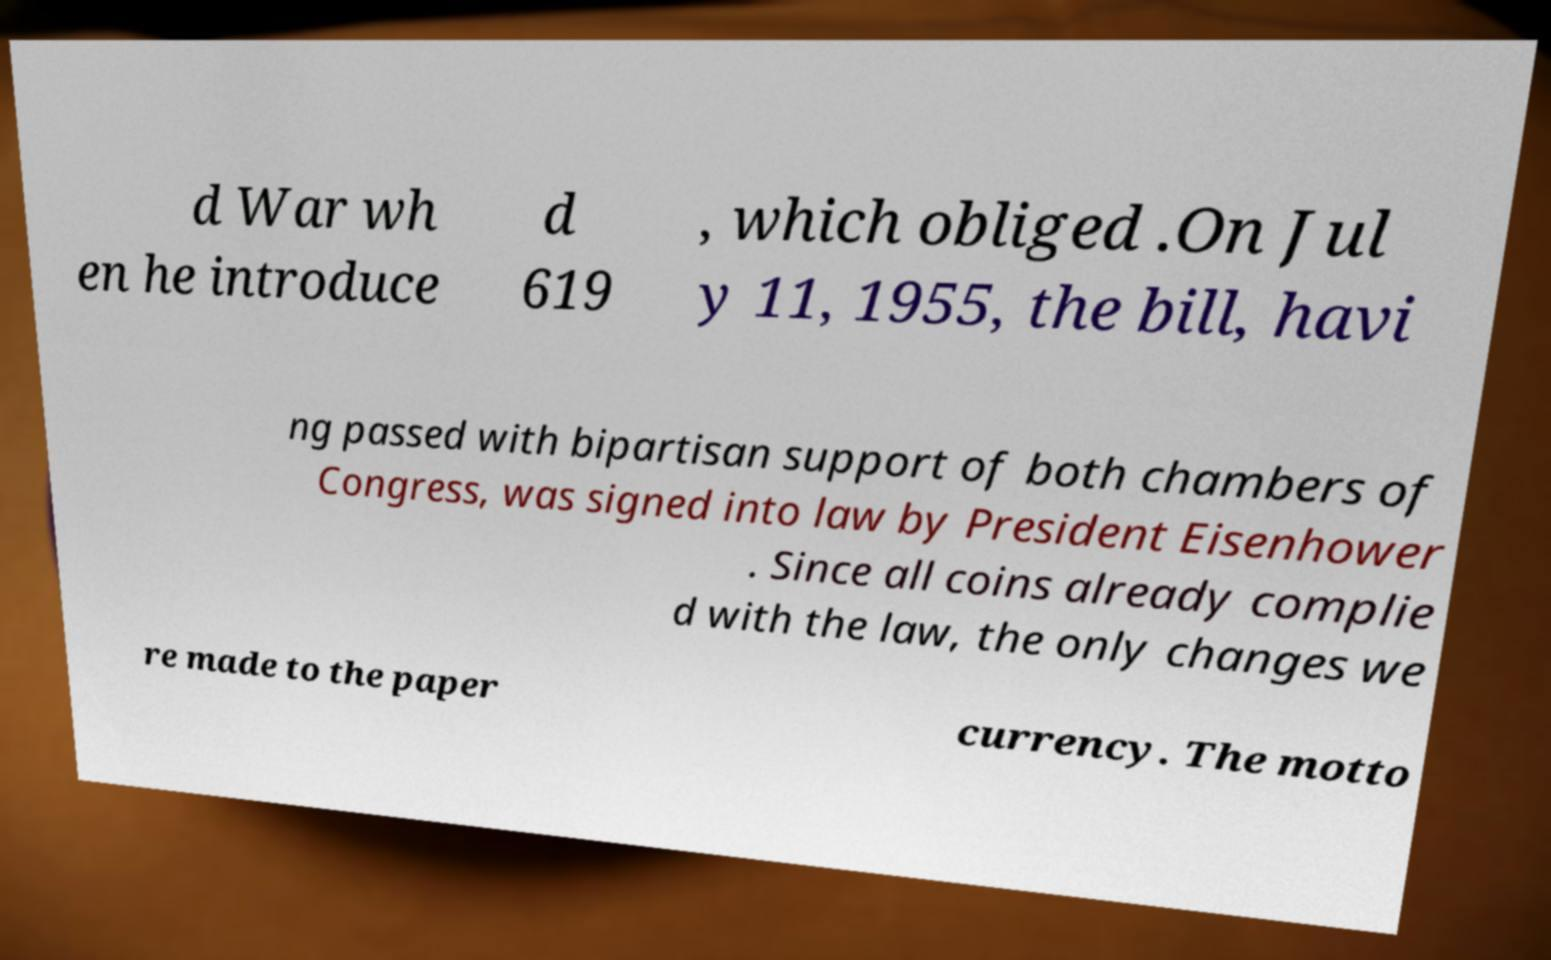Please read and relay the text visible in this image. What does it say? d War wh en he introduce d 619 , which obliged .On Jul y 11, 1955, the bill, havi ng passed with bipartisan support of both chambers of Congress, was signed into law by President Eisenhower . Since all coins already complie d with the law, the only changes we re made to the paper currency. The motto 